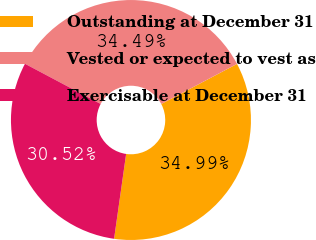Convert chart. <chart><loc_0><loc_0><loc_500><loc_500><pie_chart><fcel>Outstanding at December 31<fcel>Vested or expected to vest as<fcel>Exercisable at December 31<nl><fcel>34.99%<fcel>34.49%<fcel>30.52%<nl></chart> 